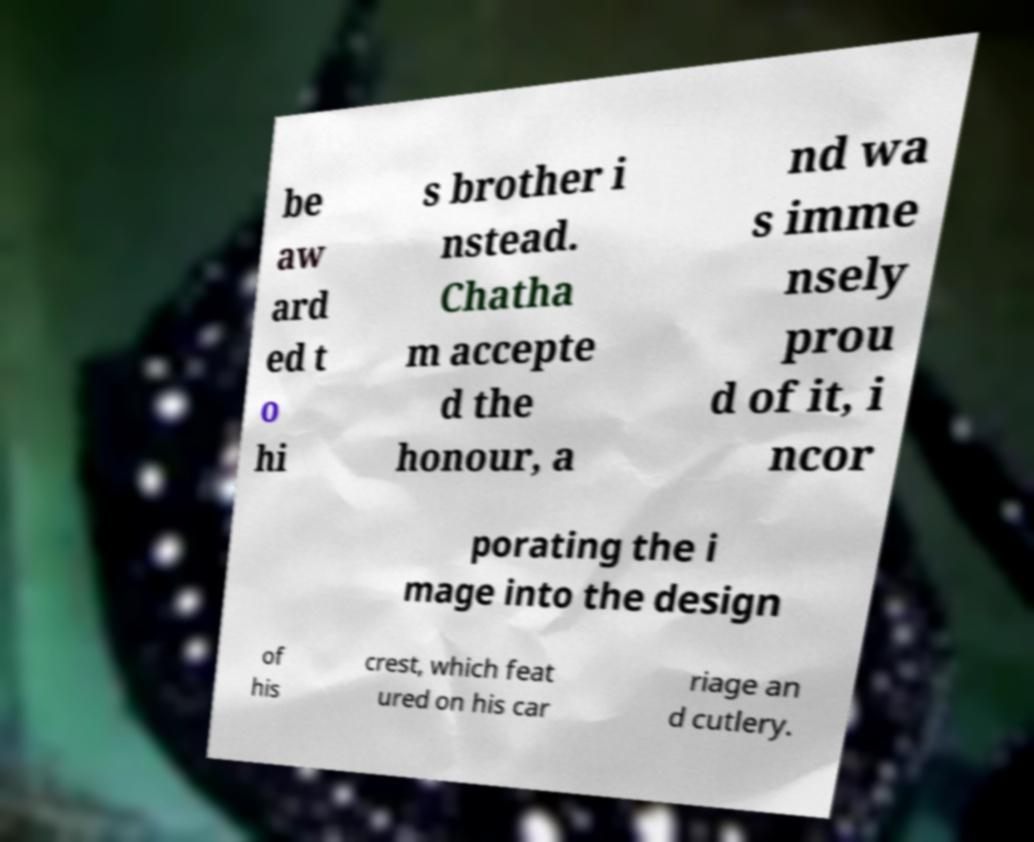Please identify and transcribe the text found in this image. be aw ard ed t o hi s brother i nstead. Chatha m accepte d the honour, a nd wa s imme nsely prou d of it, i ncor porating the i mage into the design of his crest, which feat ured on his car riage an d cutlery. 